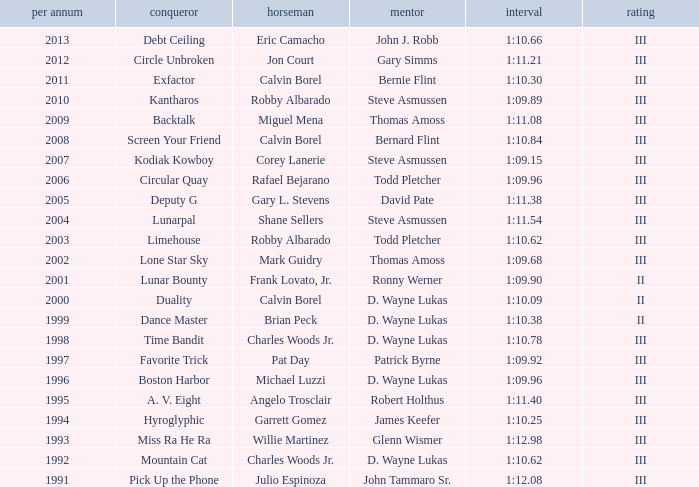Who won under Gary Simms? Circle Unbroken. 